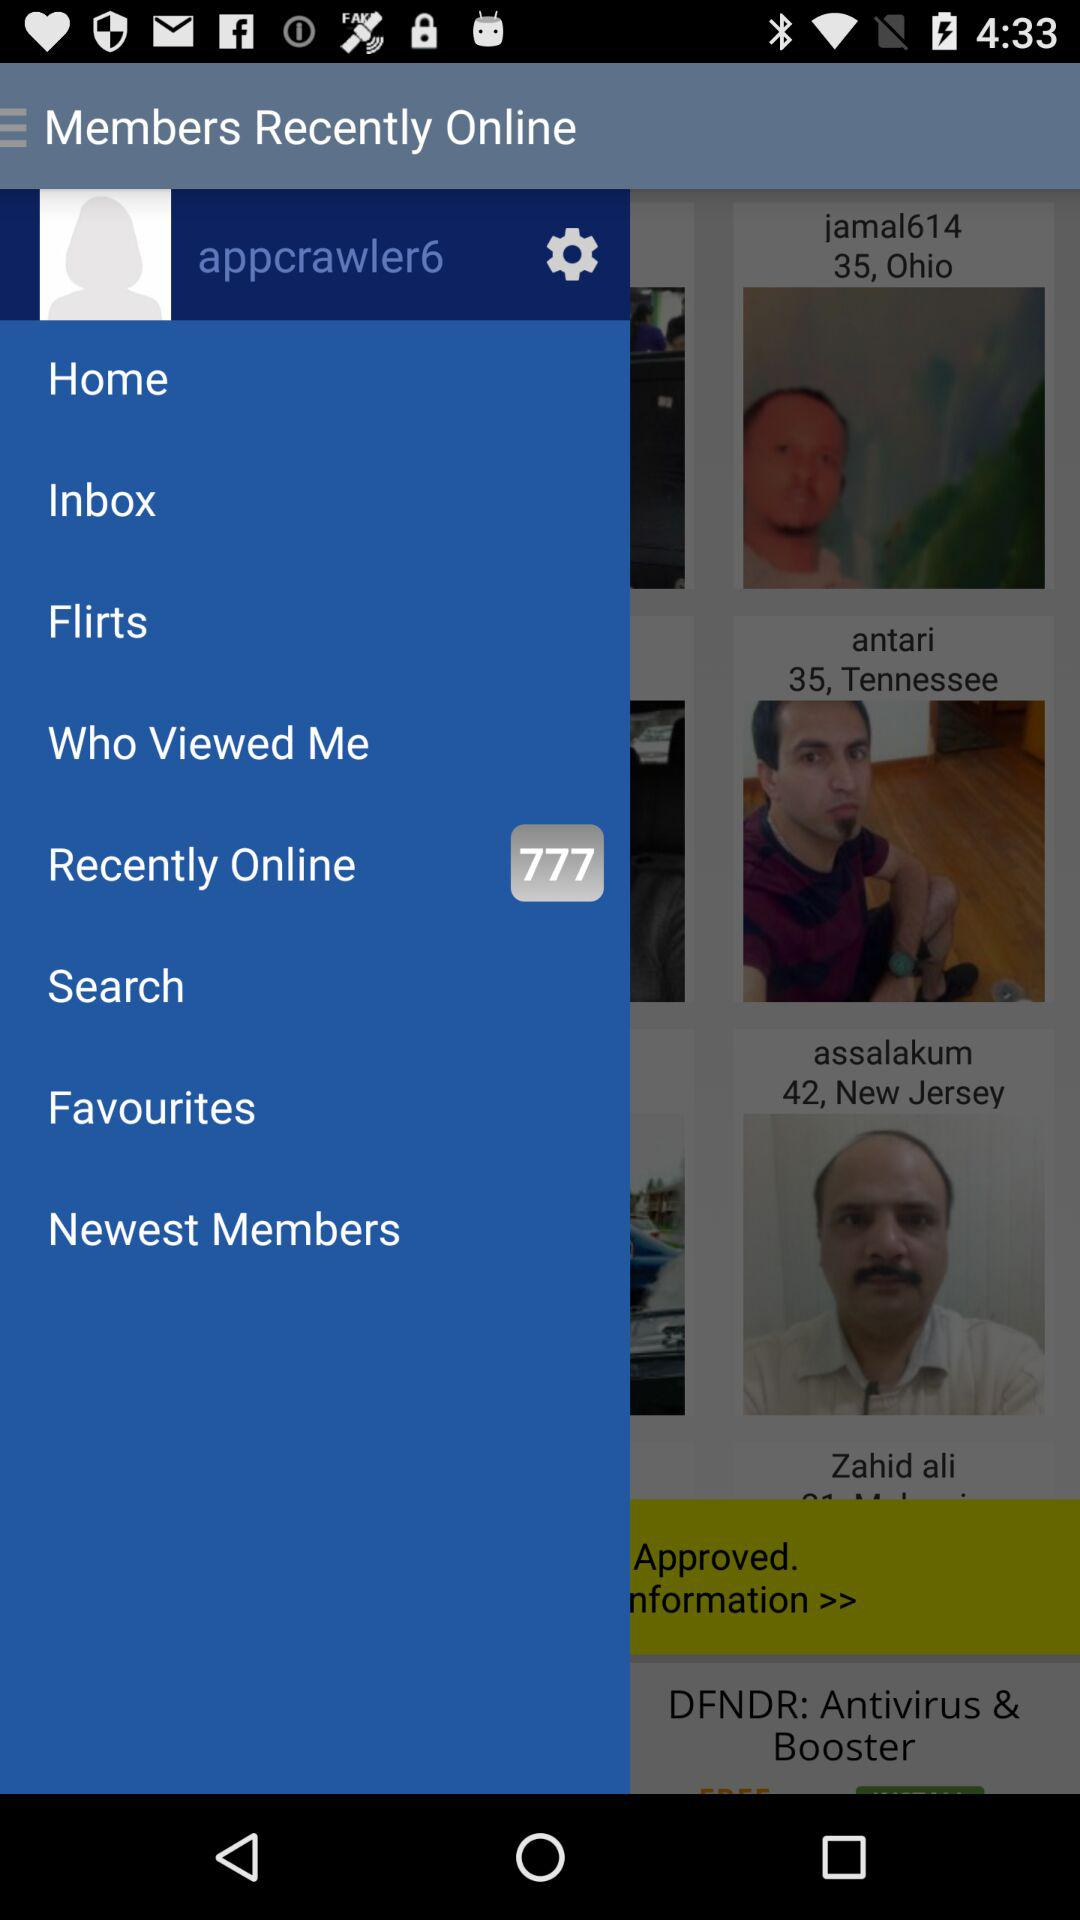What's the number of members who were recently online? The number of members who were recently online was 777. 